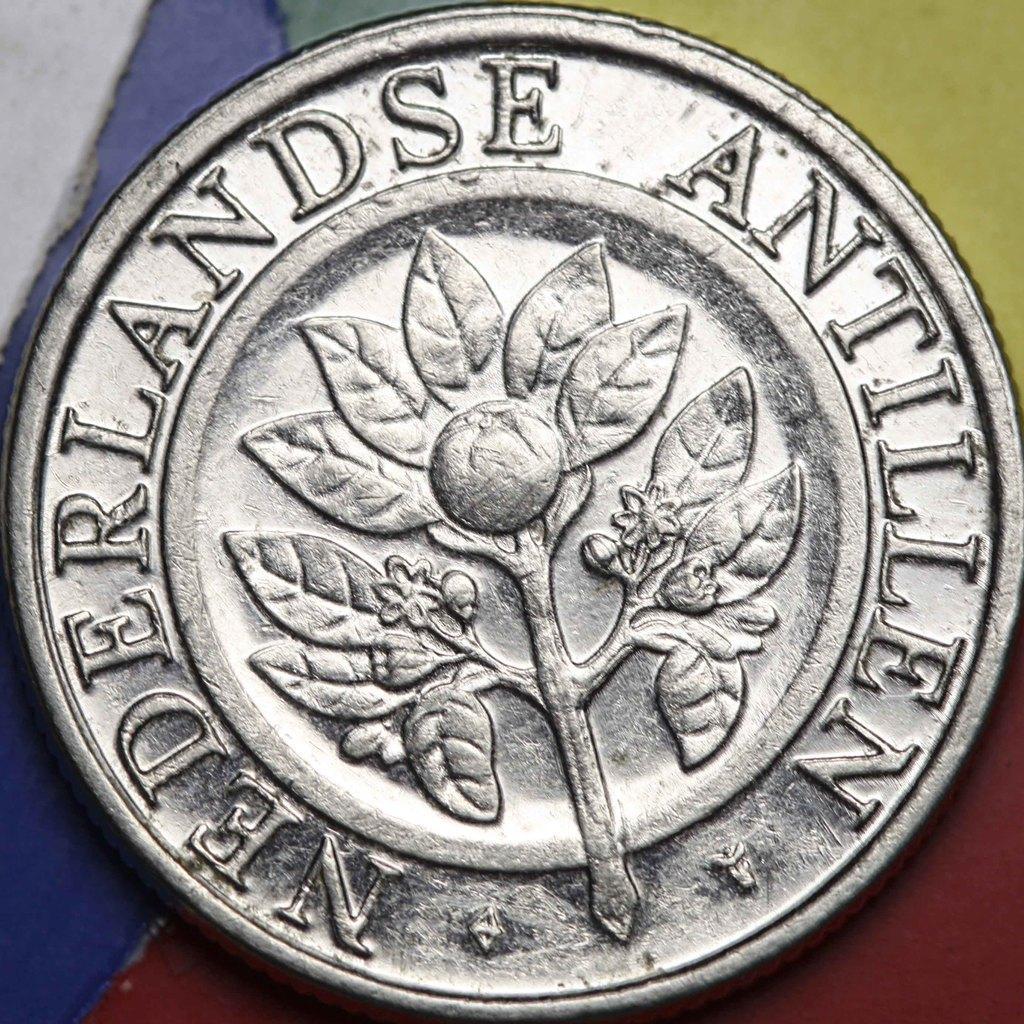In one or two sentences, can you explain what this image depicts? In the center of the image we can see a coin placed on the table. 